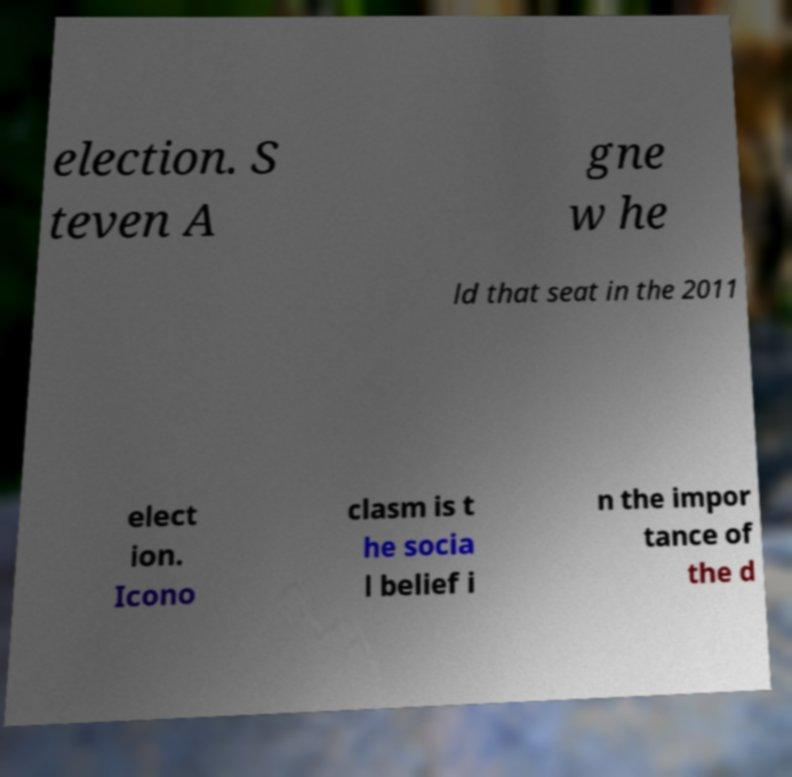Please identify and transcribe the text found in this image. election. S teven A gne w he ld that seat in the 2011 elect ion. Icono clasm is t he socia l belief i n the impor tance of the d 